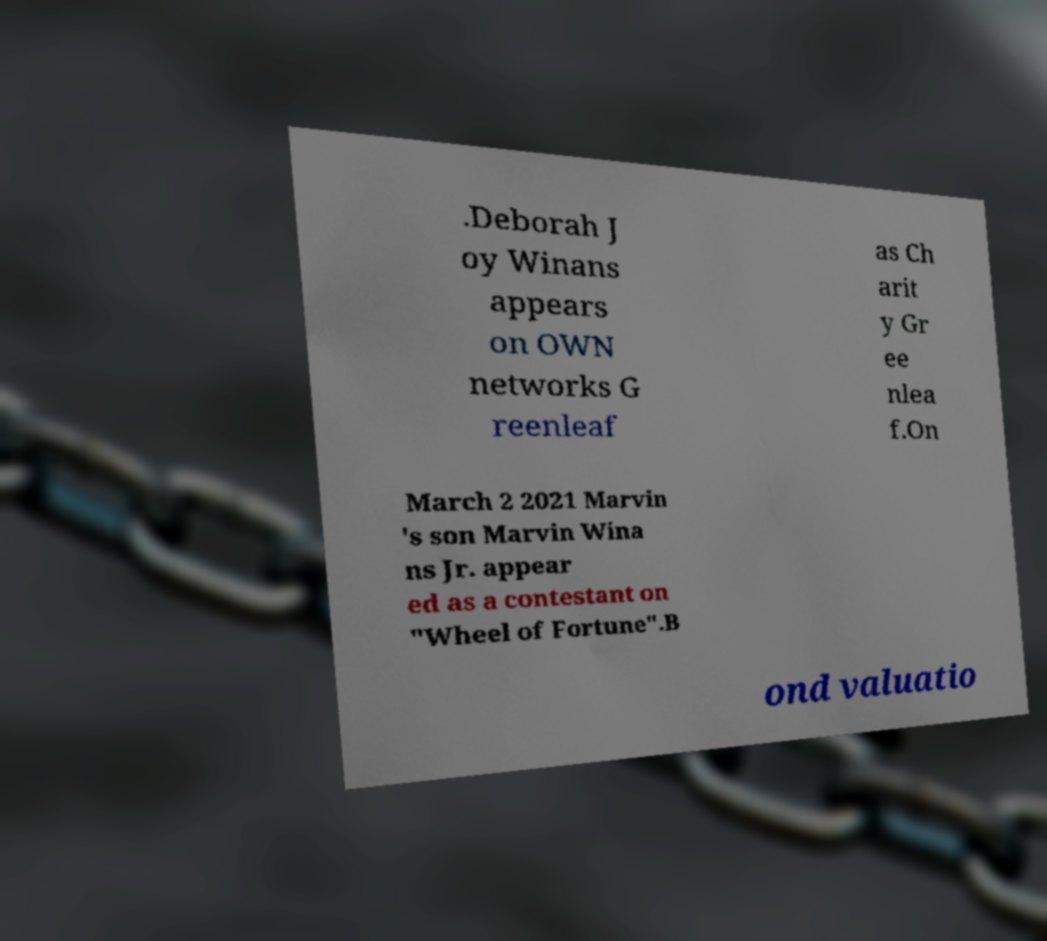What messages or text are displayed in this image? I need them in a readable, typed format. .Deborah J oy Winans appears on OWN networks G reenleaf as Ch arit y Gr ee nlea f.On March 2 2021 Marvin 's son Marvin Wina ns Jr. appear ed as a contestant on "Wheel of Fortune".B ond valuatio 